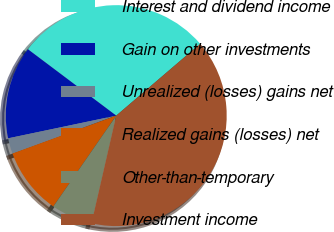<chart> <loc_0><loc_0><loc_500><loc_500><pie_chart><fcel>Interest and dividend income<fcel>Gain on other investments<fcel>Unrealized (losses) gains net<fcel>Realized gains (losses) net<fcel>Other-than-temporary<fcel>Investment income<nl><fcel>28.47%<fcel>13.55%<fcel>2.28%<fcel>9.79%<fcel>6.04%<fcel>39.86%<nl></chart> 